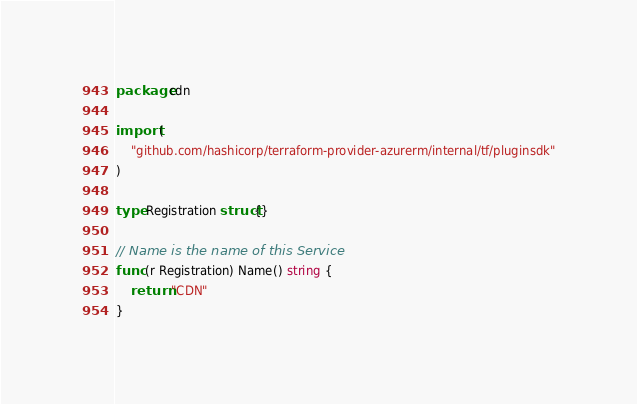<code> <loc_0><loc_0><loc_500><loc_500><_Go_>package cdn

import (
	"github.com/hashicorp/terraform-provider-azurerm/internal/tf/pluginsdk"
)

type Registration struct{}

// Name is the name of this Service
func (r Registration) Name() string {
	return "CDN"
}
</code> 